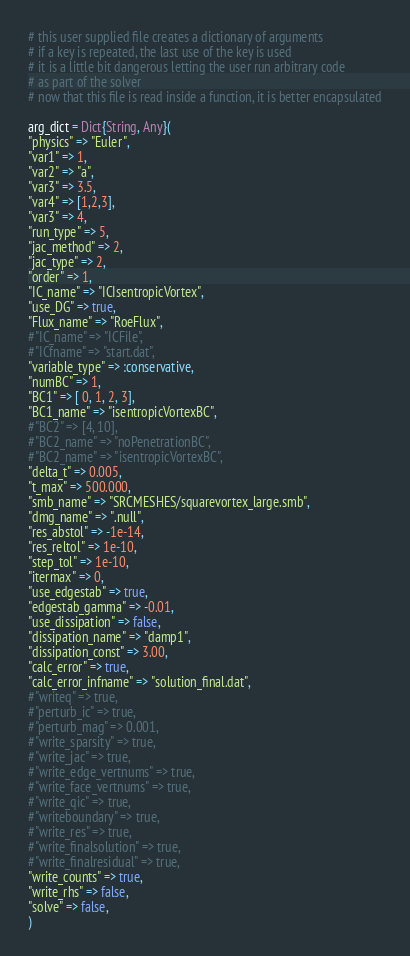Convert code to text. <code><loc_0><loc_0><loc_500><loc_500><_Julia_># this user supplied file creates a dictionary of arguments
# if a key is repeated, the last use of the key is used
# it is a little bit dangerous letting the user run arbitrary code
# as part of the solver
# now that this file is read inside a function, it is better encapsulated

arg_dict = Dict{String, Any}(
"physics" => "Euler",
"var1" => 1,
"var2" => "a",
"var3" => 3.5,
"var4" => [1,2,3],
"var3" => 4,
"run_type" => 5,
"jac_method" => 2,
"jac_type" => 2,
"order" => 1,
"IC_name" => "ICIsentropicVortex",
"use_DG" => true,
"Flux_name" => "RoeFlux",
#"IC_name" => "ICFile",
#"ICfname" => "start.dat",
"variable_type" => :conservative,
"numBC" => 1,
"BC1" => [ 0, 1, 2, 3],
"BC1_name" => "isentropicVortexBC",
#"BC2" => [4, 10],
#"BC2_name" => "noPenetrationBC",
#"BC2_name" => "isentropicVortexBC",
"delta_t" => 0.005,
"t_max" => 500.000,
"smb_name" => "SRCMESHES/squarevortex_large.smb",
"dmg_name" => ".null",
"res_abstol" => -1e-14,
"res_reltol" => 1e-10,
"step_tol" => 1e-10,
"itermax" => 0,
"use_edgestab" => true,
"edgestab_gamma" => -0.01,
"use_dissipation" => false,
"dissipation_name" => "damp1",
"dissipation_const" => 3.00,
"calc_error" => true,
"calc_error_infname" => "solution_final.dat",
#"writeq" => true,
#"perturb_ic" => true,
#"perturb_mag" => 0.001,
#"write_sparsity" => true,
#"write_jac" => true,
#"write_edge_vertnums" => true,
#"write_face_vertnums" => true,
#"write_qic" => true,
#"writeboundary" => true,
#"write_res" => true,
#"write_finalsolution" => true,
#"write_finalresidual" => true,
"write_counts" => true,
"write_rhs" => false,
"solve" => false,
)
</code> 